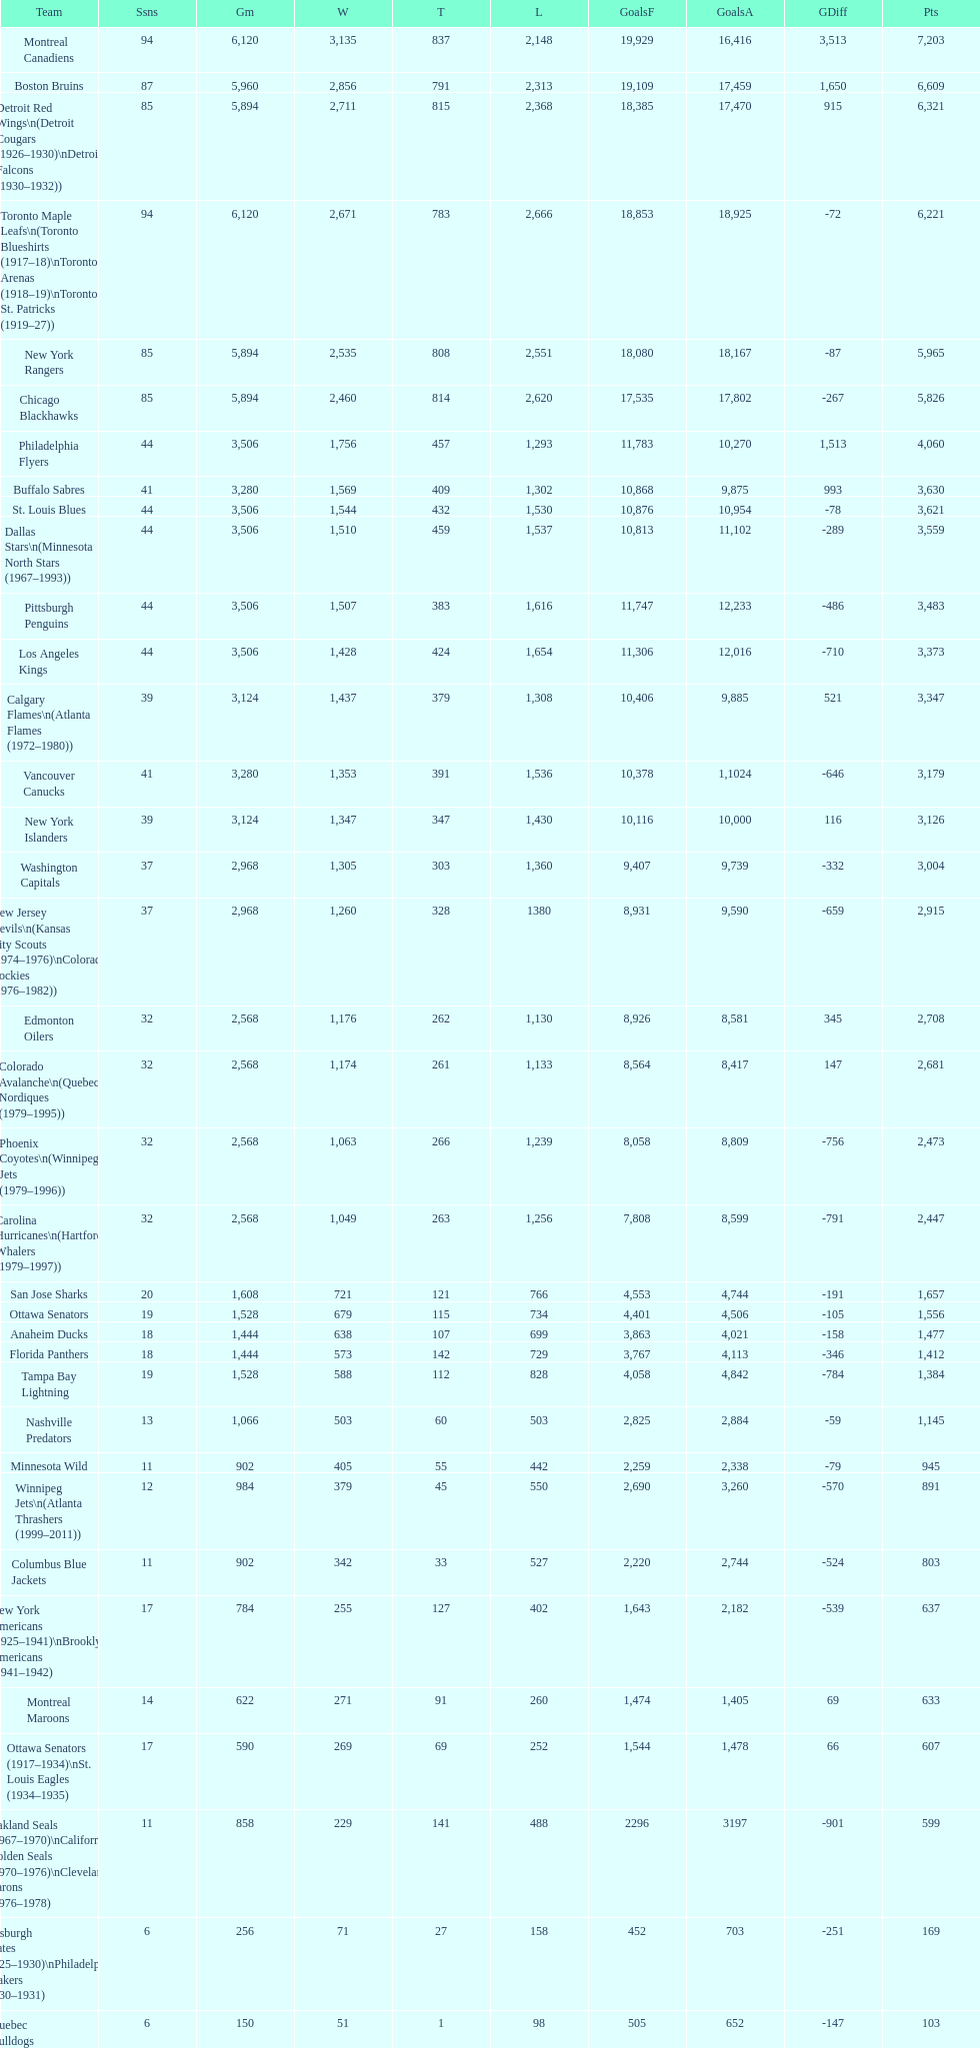Which team was last in terms of points up until this point? Montreal Wanderers. 